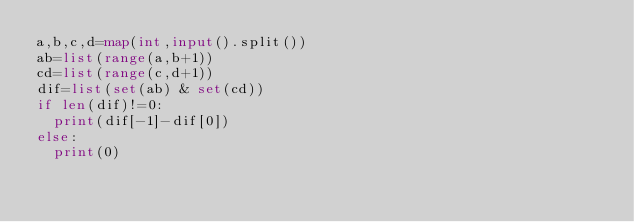<code> <loc_0><loc_0><loc_500><loc_500><_Python_>a,b,c,d=map(int,input().split())
ab=list(range(a,b+1))
cd=list(range(c,d+1))
dif=list(set(ab) & set(cd))
if len(dif)!=0:
  print(dif[-1]-dif[0])
else:
  print(0)
</code> 